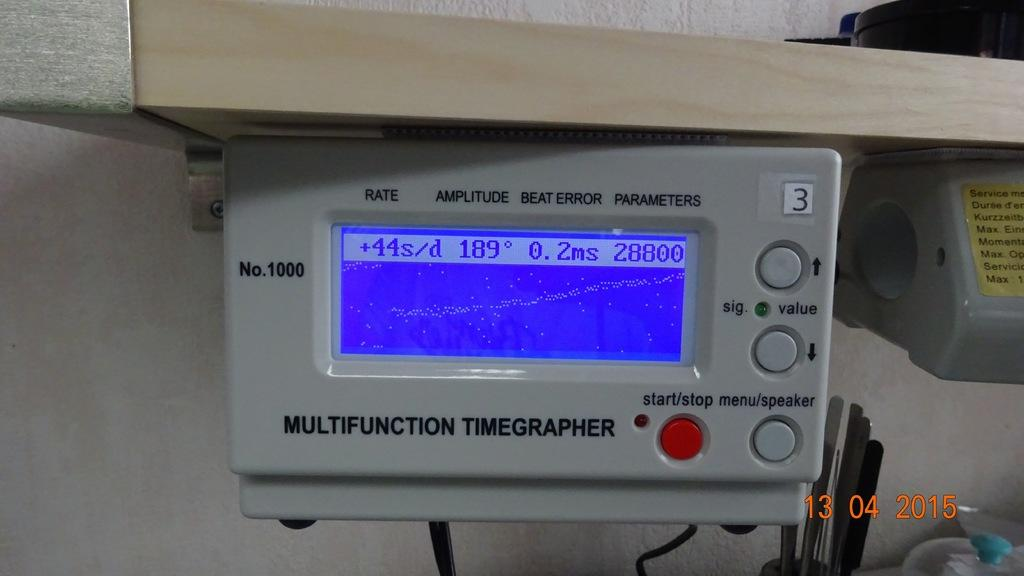What is the main object in the image? There is a machine in the image. What features does the machine have? The machine has a display and buttons. Can you tell me the date visible in the image? The date is visible in the bottom right corner of the image. How many servants are attending to the machine in the image? There are no servants present in the image; it only features the machine. What type of crack can be seen on the display of the machine? There is no crack visible on the display of the machine in the image. 